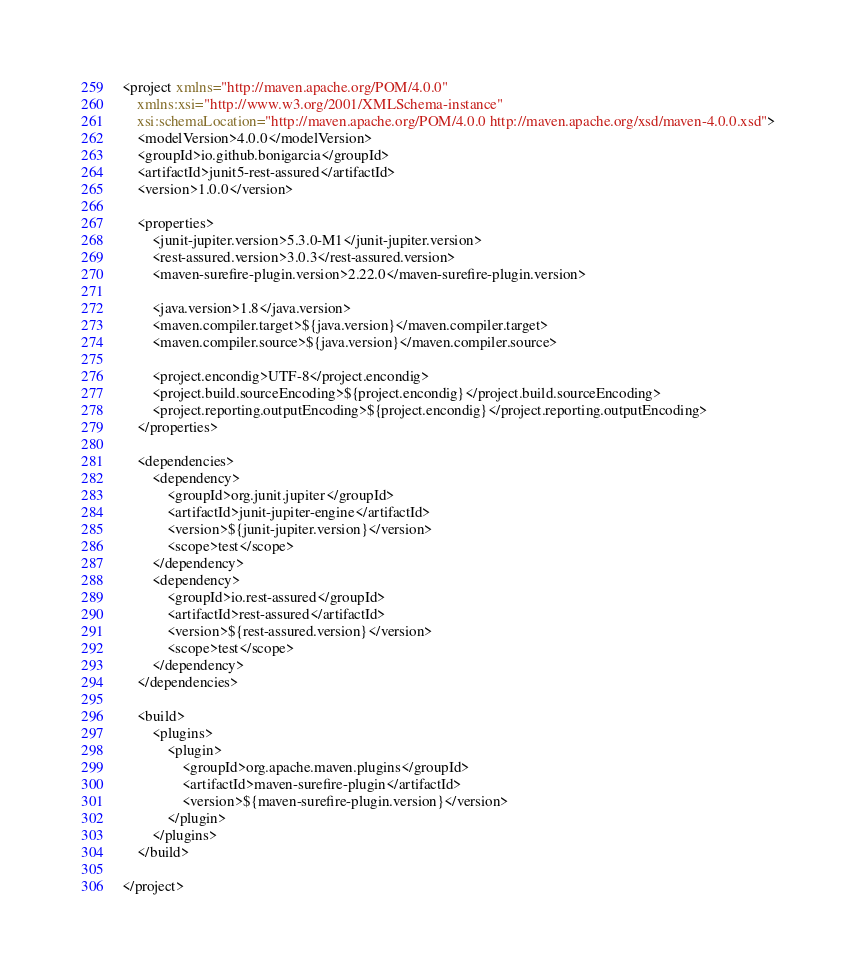<code> <loc_0><loc_0><loc_500><loc_500><_XML_><project xmlns="http://maven.apache.org/POM/4.0.0"
    xmlns:xsi="http://www.w3.org/2001/XMLSchema-instance"
    xsi:schemaLocation="http://maven.apache.org/POM/4.0.0 http://maven.apache.org/xsd/maven-4.0.0.xsd">
    <modelVersion>4.0.0</modelVersion>
    <groupId>io.github.bonigarcia</groupId>
    <artifactId>junit5-rest-assured</artifactId>
    <version>1.0.0</version>

    <properties>
        <junit-jupiter.version>5.3.0-M1</junit-jupiter.version>
        <rest-assured.version>3.0.3</rest-assured.version>
        <maven-surefire-plugin.version>2.22.0</maven-surefire-plugin.version>

        <java.version>1.8</java.version>
        <maven.compiler.target>${java.version}</maven.compiler.target>
        <maven.compiler.source>${java.version}</maven.compiler.source>

        <project.encondig>UTF-8</project.encondig>
        <project.build.sourceEncoding>${project.encondig}</project.build.sourceEncoding>
        <project.reporting.outputEncoding>${project.encondig}</project.reporting.outputEncoding>
    </properties>

    <dependencies>
        <dependency>
            <groupId>org.junit.jupiter</groupId>
            <artifactId>junit-jupiter-engine</artifactId>
            <version>${junit-jupiter.version}</version>
            <scope>test</scope>
        </dependency>
        <dependency>
            <groupId>io.rest-assured</groupId>
            <artifactId>rest-assured</artifactId>
            <version>${rest-assured.version}</version>
            <scope>test</scope>
        </dependency>
    </dependencies>

    <build>
        <plugins>
            <plugin>
                <groupId>org.apache.maven.plugins</groupId>
                <artifactId>maven-surefire-plugin</artifactId>
                <version>${maven-surefire-plugin.version}</version>
            </plugin>
        </plugins>
    </build>

</project></code> 